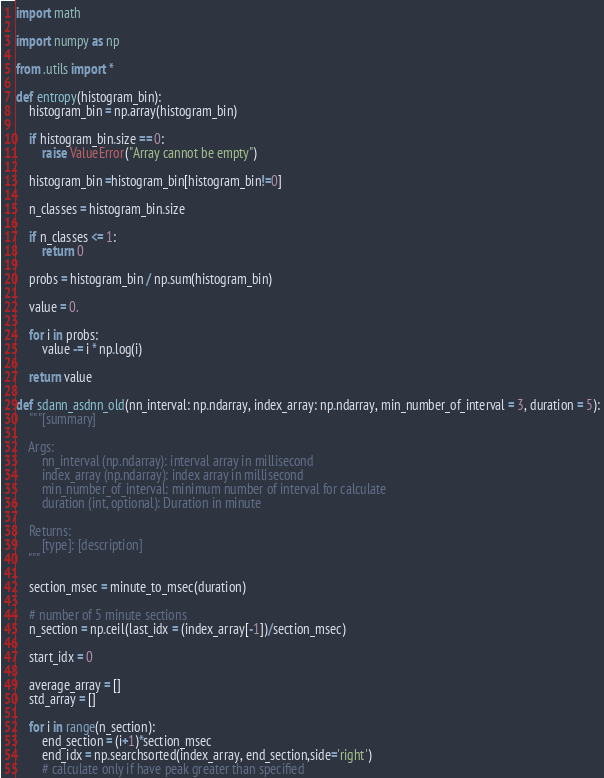<code> <loc_0><loc_0><loc_500><loc_500><_Python_>import math

import numpy as np

from .utils import *

def entropy(histogram_bin):
    histogram_bin = np.array(histogram_bin)

    if histogram_bin.size == 0:
        raise ValueError("Array cannot be empty")

    histogram_bin =histogram_bin[histogram_bin!=0]
 
    n_classes = histogram_bin.size

    if n_classes <= 1:
        return 0

    probs = histogram_bin / np.sum(histogram_bin)

    value = 0.

    for i in probs:
        value -= i * np.log(i)

    return value

def sdann_asdnn_old(nn_interval: np.ndarray, index_array: np.ndarray, min_number_of_interval = 3, duration = 5):
    """[summary]

    Args:
        nn_interval (np.ndarray): interval array in millisecond
        index_array (np.ndarray): index array in millisecond
        min_number_of_interval: minimum number of interval for calculate
        duration (int, optional): Duration in minute

    Returns:
        [type]: [description]
    """

    section_msec = minute_to_msec(duration)

    # number of 5 minute sections
    n_section = np.ceil(last_idx = (index_array[-1])/section_msec)

    start_idx = 0

    average_array = []
    std_array = []

    for i in range(n_section):
        end_section = (i+1)*section_msec
        end_idx = np.searchsorted(index_array, end_section,side='right')
        # calculate only if have peak greater than specified</code> 